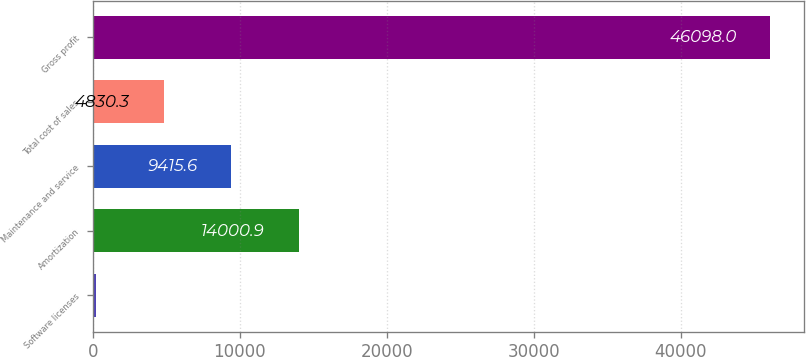<chart> <loc_0><loc_0><loc_500><loc_500><bar_chart><fcel>Software licenses<fcel>Amortization<fcel>Maintenance and service<fcel>Total cost of sales<fcel>Gross profit<nl><fcel>245<fcel>14000.9<fcel>9415.6<fcel>4830.3<fcel>46098<nl></chart> 